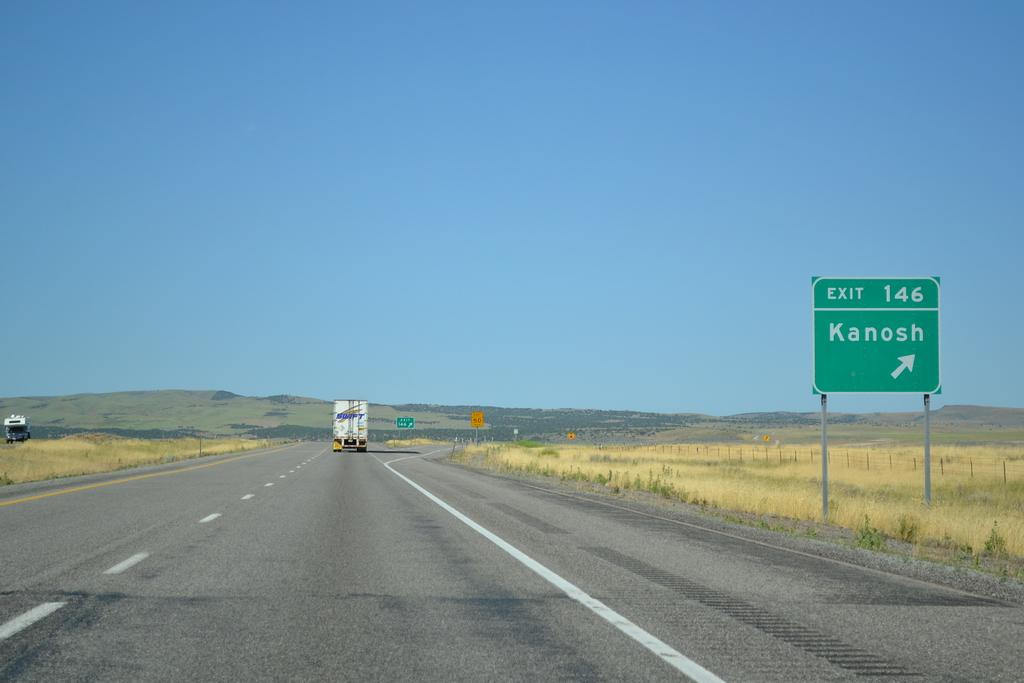Provide a one-sentence caption for the provided image. A green exit 146 signs to Kanosh stands along a highway. 